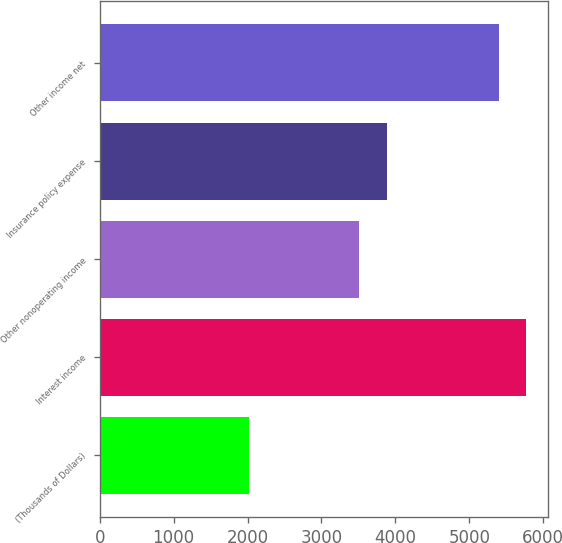Convert chart to OTSL. <chart><loc_0><loc_0><loc_500><loc_500><bar_chart><fcel>(Thousands of Dollars)<fcel>Interest income<fcel>Other nonoperating income<fcel>Insurance policy expense<fcel>Other income net<nl><fcel>2015<fcel>5772.2<fcel>3514<fcel>3886.2<fcel>5400<nl></chart> 